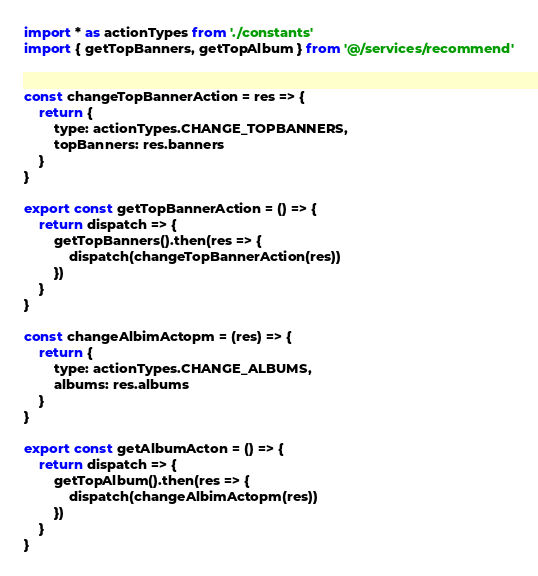<code> <loc_0><loc_0><loc_500><loc_500><_JavaScript_>import * as actionTypes from './constants'
import { getTopBanners, getTopAlbum } from '@/services/recommend'


const changeTopBannerAction = res => {
    return {
        type: actionTypes.CHANGE_TOPBANNERS,
        topBanners: res.banners
    }
}

export const getTopBannerAction = () => {
    return dispatch => {
        getTopBanners().then(res => {
            dispatch(changeTopBannerAction(res))
        })
    }
}

const changeAlbimActopm = (res) => {
    return {
        type: actionTypes.CHANGE_ALBUMS,
        albums: res.albums
    }
}

export const getAlbumActon = () => {
    return dispatch => {
        getTopAlbum().then(res => {
            dispatch(changeAlbimActopm(res))
        })
    }
}
</code> 